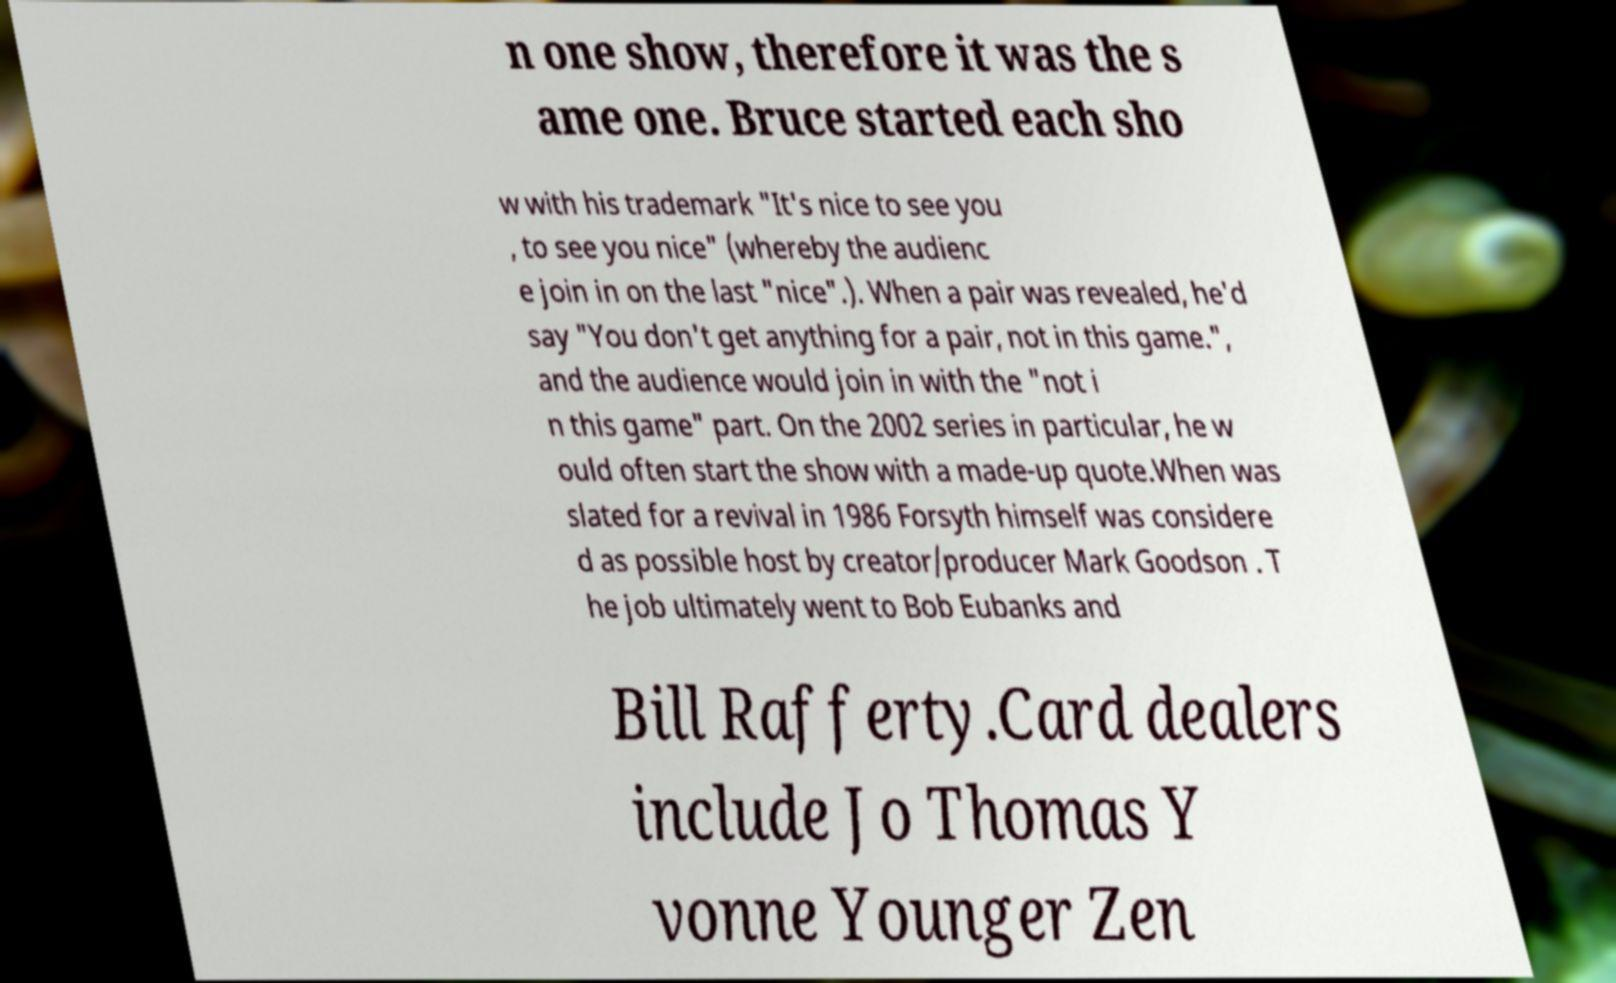There's text embedded in this image that I need extracted. Can you transcribe it verbatim? n one show, therefore it was the s ame one. Bruce started each sho w with his trademark "It's nice to see you , to see you nice" (whereby the audienc e join in on the last "nice".). When a pair was revealed, he'd say "You don't get anything for a pair, not in this game.", and the audience would join in with the "not i n this game" part. On the 2002 series in particular, he w ould often start the show with a made-up quote.When was slated for a revival in 1986 Forsyth himself was considere d as possible host by creator/producer Mark Goodson . T he job ultimately went to Bob Eubanks and Bill Rafferty.Card dealers include Jo Thomas Y vonne Younger Zen 